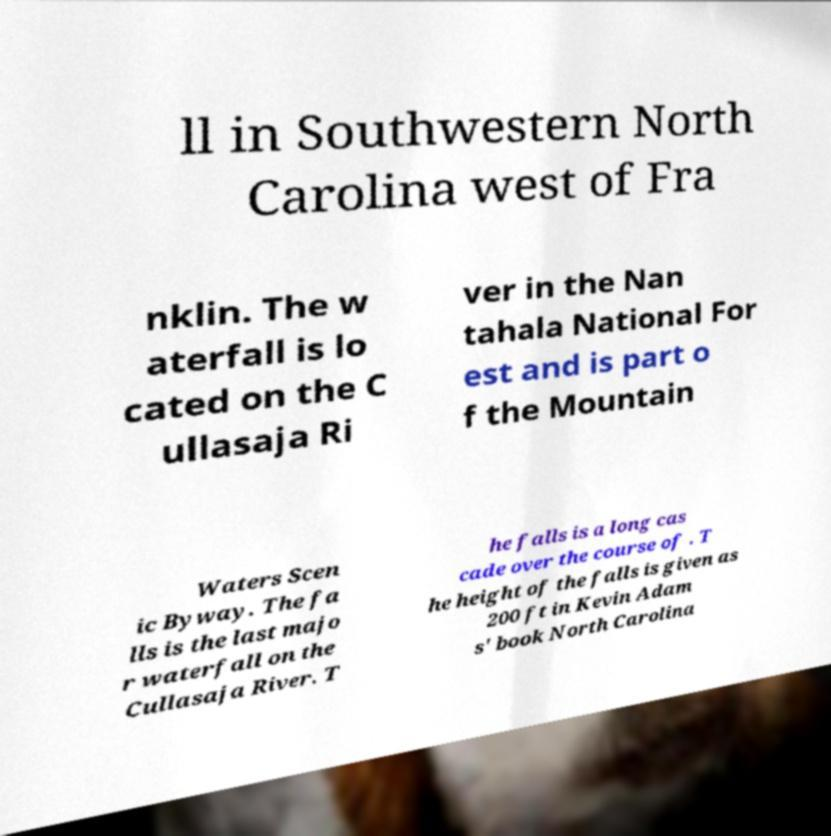Can you read and provide the text displayed in the image?This photo seems to have some interesting text. Can you extract and type it out for me? ll in Southwestern North Carolina west of Fra nklin. The w aterfall is lo cated on the C ullasaja Ri ver in the Nan tahala National For est and is part o f the Mountain Waters Scen ic Byway. The fa lls is the last majo r waterfall on the Cullasaja River. T he falls is a long cas cade over the course of . T he height of the falls is given as 200 ft in Kevin Adam s' book North Carolina 